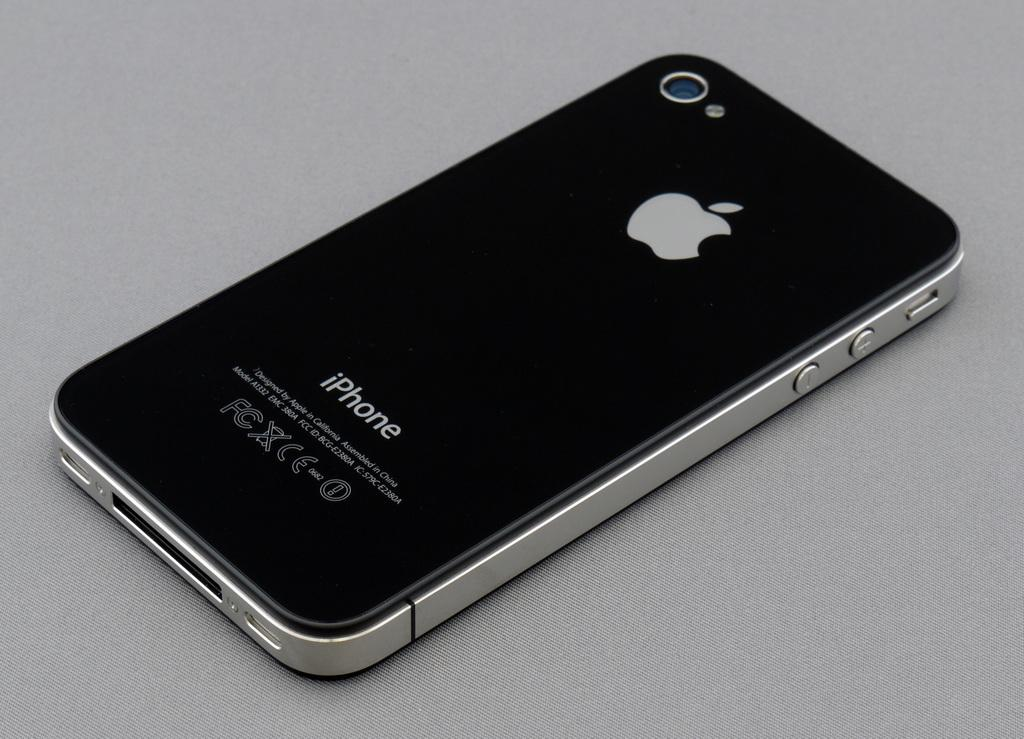Provide a one-sentence caption for the provided image. A photo of the back of an Apple iPhone. 